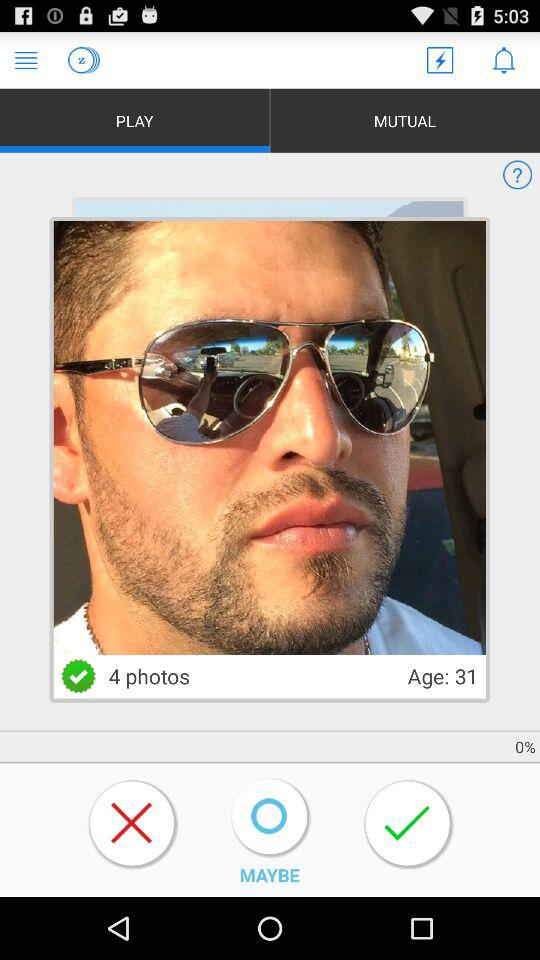What is the age of the person? The age of the person is 31 years. 